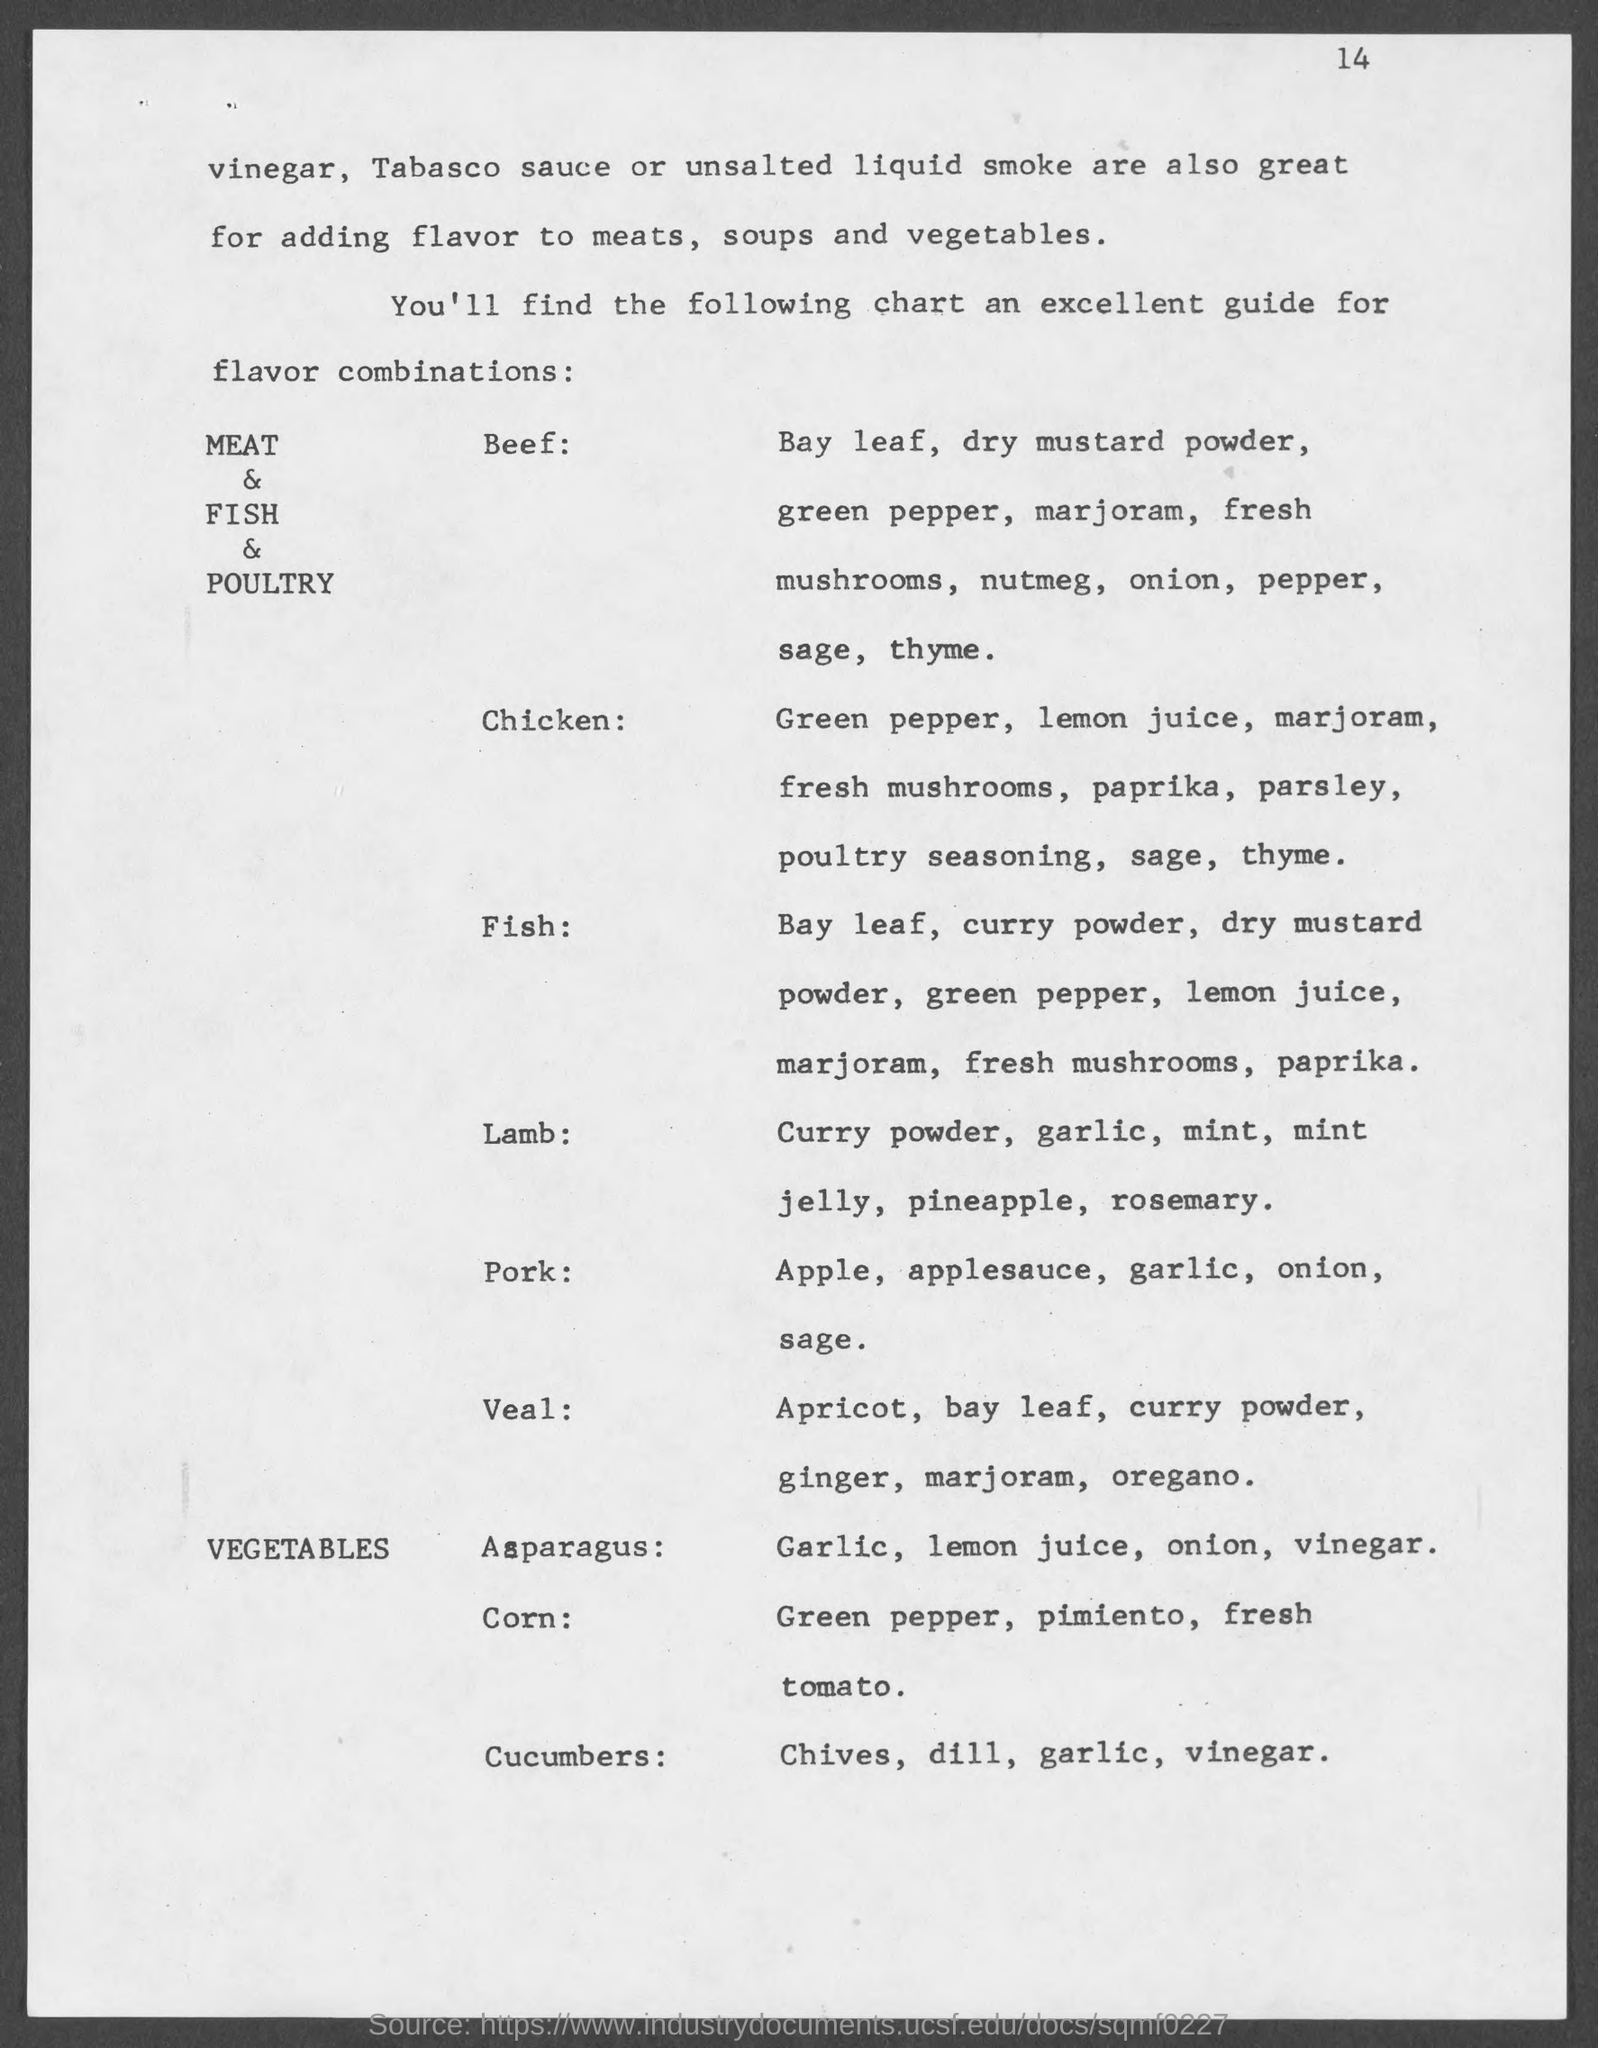What is the page number at top of the page?
Give a very brief answer. 14. 